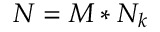Convert formula to latex. <formula><loc_0><loc_0><loc_500><loc_500>N = M * N _ { k }</formula> 